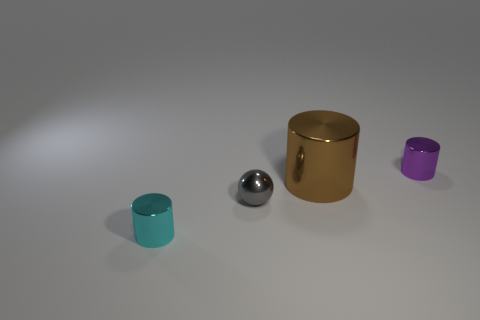Which object stands out the most, and why? The large brown cylinder stands out the most due to its size and shiny gold finish that contrasts with the matte appearance of the other objects and the neutral background. 